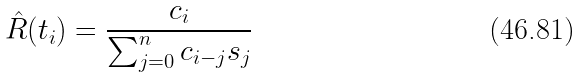<formula> <loc_0><loc_0><loc_500><loc_500>\hat { R } ( t _ { i } ) = \frac { c _ { i } } { \sum _ { j = 0 } ^ { n } c _ { i - j } s _ { j } }</formula> 